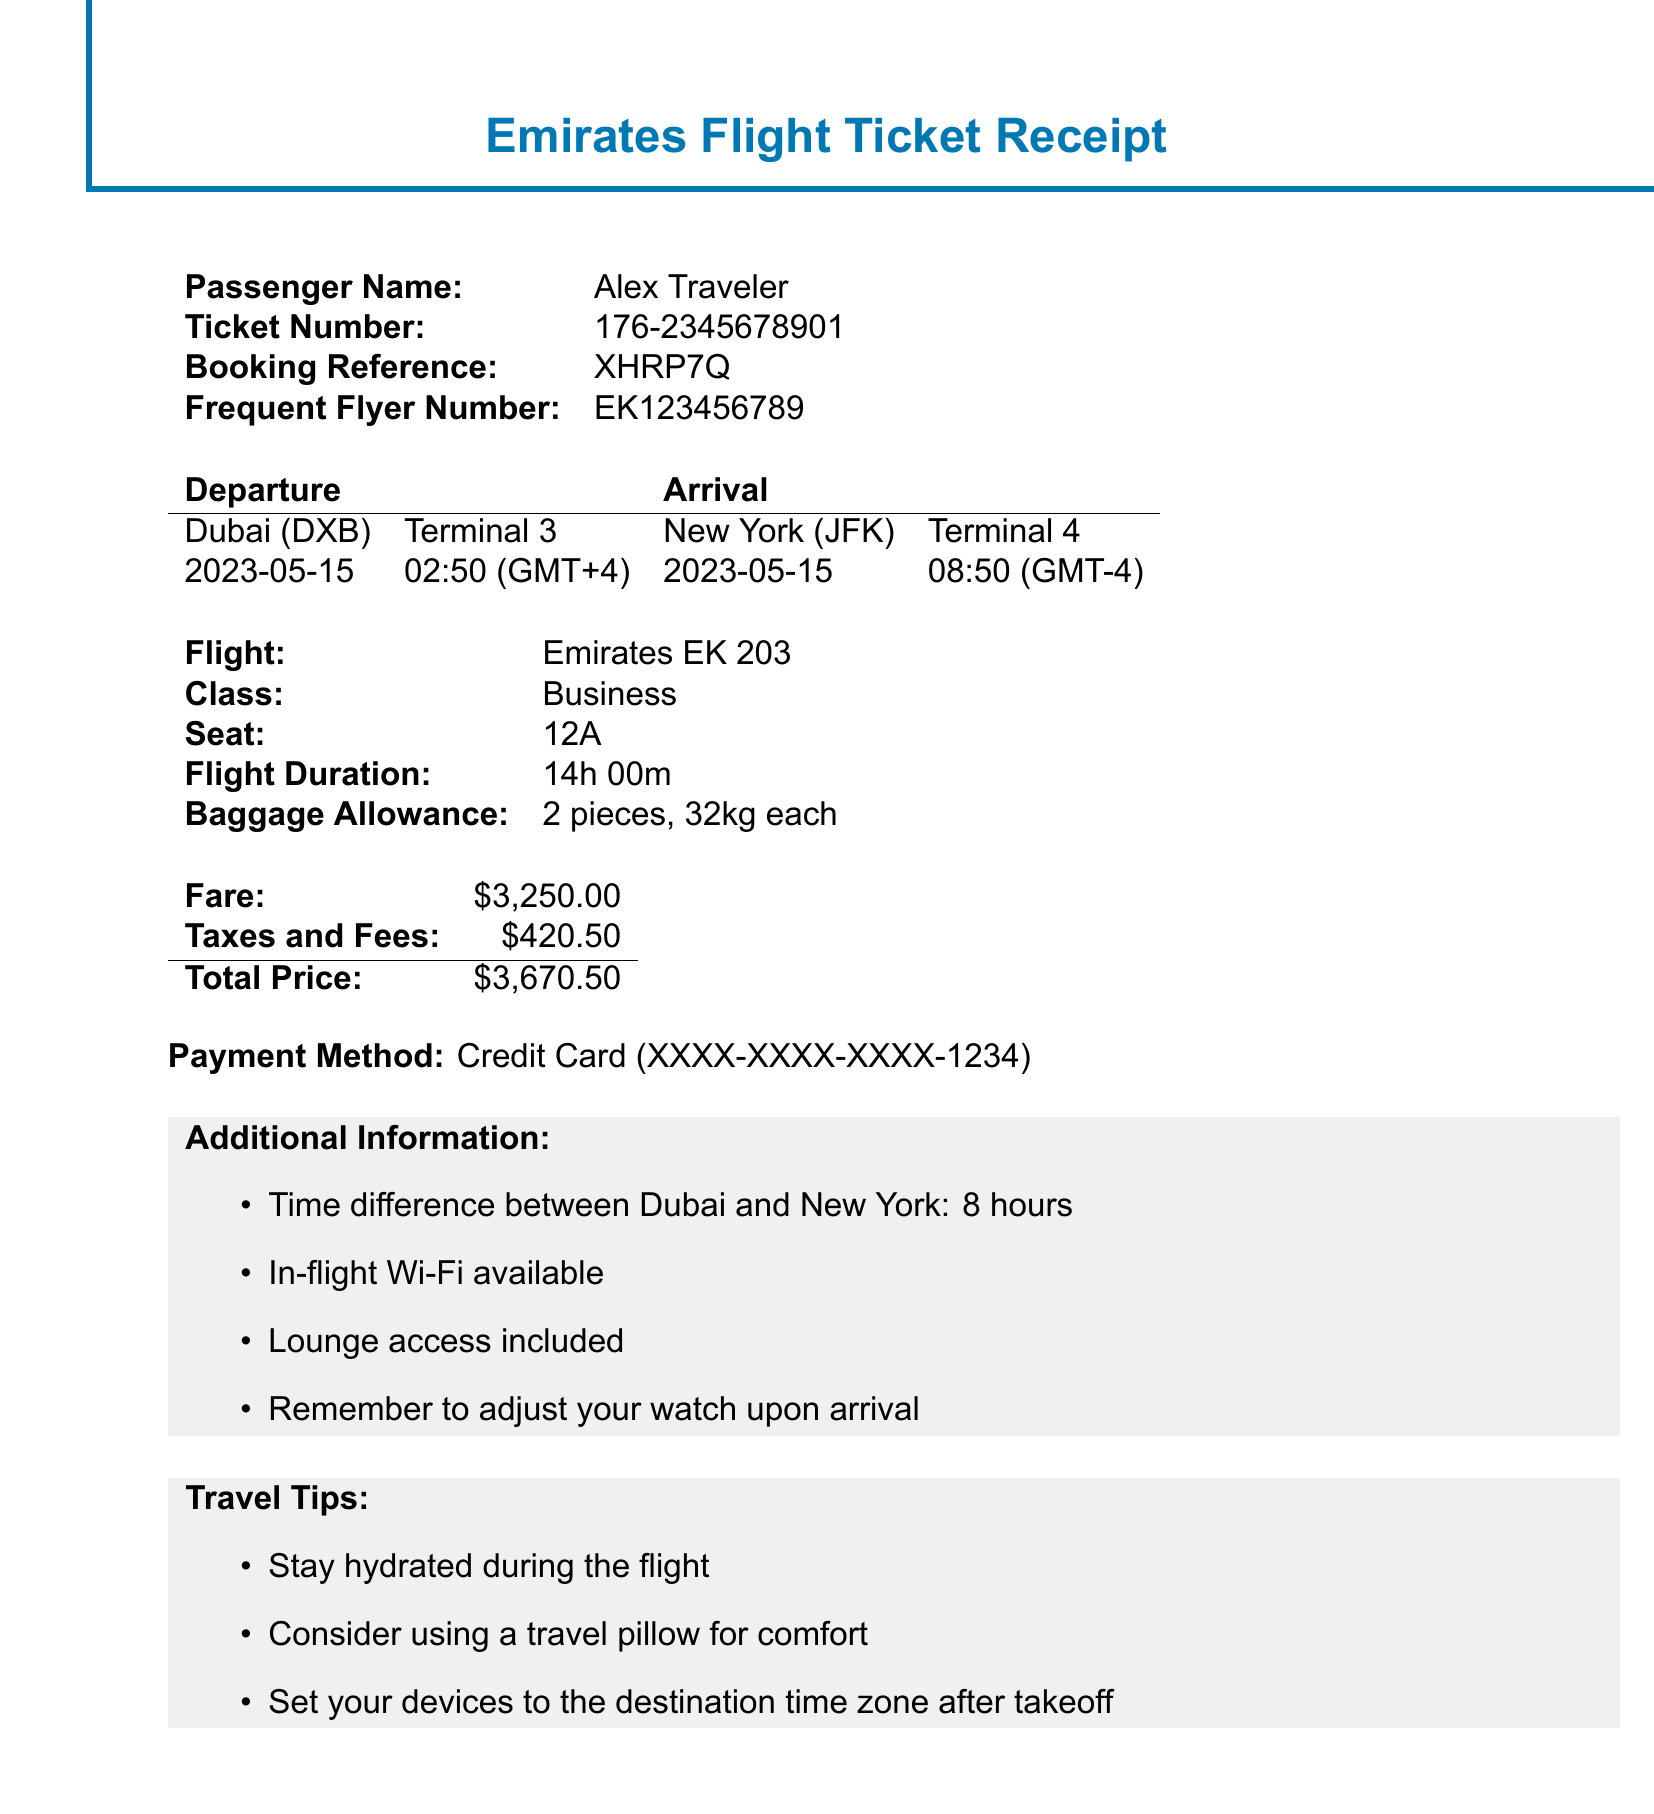What is the flight number? The flight number is specified in the receipt, which is Emirates EK 203.
Answer: EK 203 What is the departure airport code? The departure airport code is provided in the document under the departure airport section, which is DXB.
Answer: DXB What is the total price of the ticket? The total price is listed at the end of the document, which includes fare and taxes, amounting to $3,670.50.
Answer: $3,670.50 What time does the flight depart locally? The local departure time is stated in the document, which is 02:50.
Answer: 02:50 What is the flight duration? The flight duration is mentioned in the ticket receipt, which is 14 hours and 0 minutes.
Answer: 14h 00m What is the time difference between Dubai and New York? The time difference is mentioned in the additional information section as 8 hours.
Answer: 8 hours In which class is the passenger traveling? The class of travel is indicated as Business in the receipt.
Answer: Business What is included in the baggage allowance? The baggage allowance details are provided in the document, stating 2 pieces, 32kg each.
Answer: 2 pieces, 32kg each What terminal will the arrival take place? The arrival terminal is specified in the document for New York, which is Terminal 4.
Answer: Terminal 4 